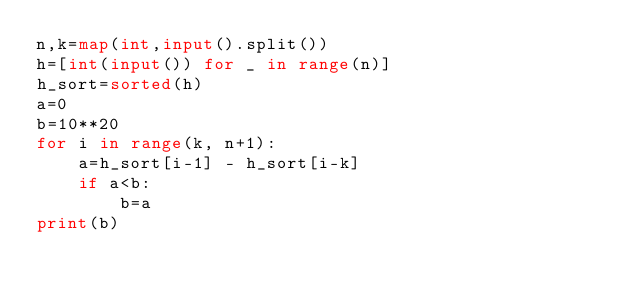Convert code to text. <code><loc_0><loc_0><loc_500><loc_500><_Python_>n,k=map(int,input().split())
h=[int(input()) for _ in range(n)]
h_sort=sorted(h)
a=0
b=10**20
for i in range(k, n+1):
	a=h_sort[i-1] - h_sort[i-k]
	if a<b:
		b=a
print(b)</code> 